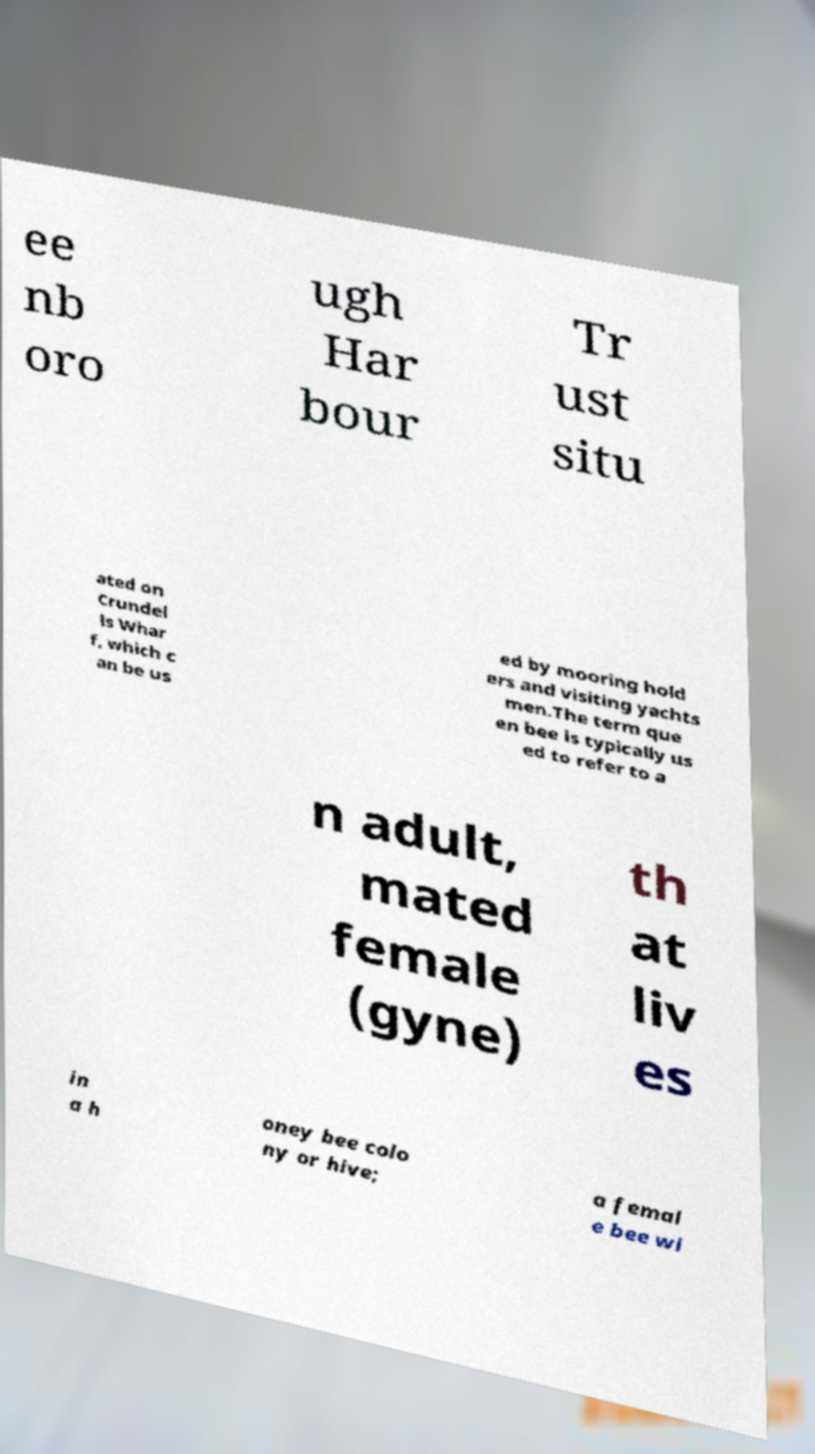Please read and relay the text visible in this image. What does it say? ee nb oro ugh Har bour Tr ust situ ated on Crundel ls Whar f, which c an be us ed by mooring hold ers and visiting yachts men.The term que en bee is typically us ed to refer to a n adult, mated female (gyne) th at liv es in a h oney bee colo ny or hive; a femal e bee wi 